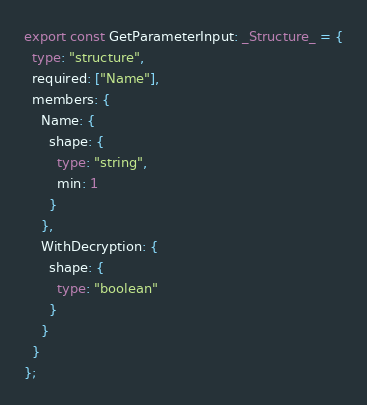Convert code to text. <code><loc_0><loc_0><loc_500><loc_500><_TypeScript_>
export const GetParameterInput: _Structure_ = {
  type: "structure",
  required: ["Name"],
  members: {
    Name: {
      shape: {
        type: "string",
        min: 1
      }
    },
    WithDecryption: {
      shape: {
        type: "boolean"
      }
    }
  }
};
</code> 